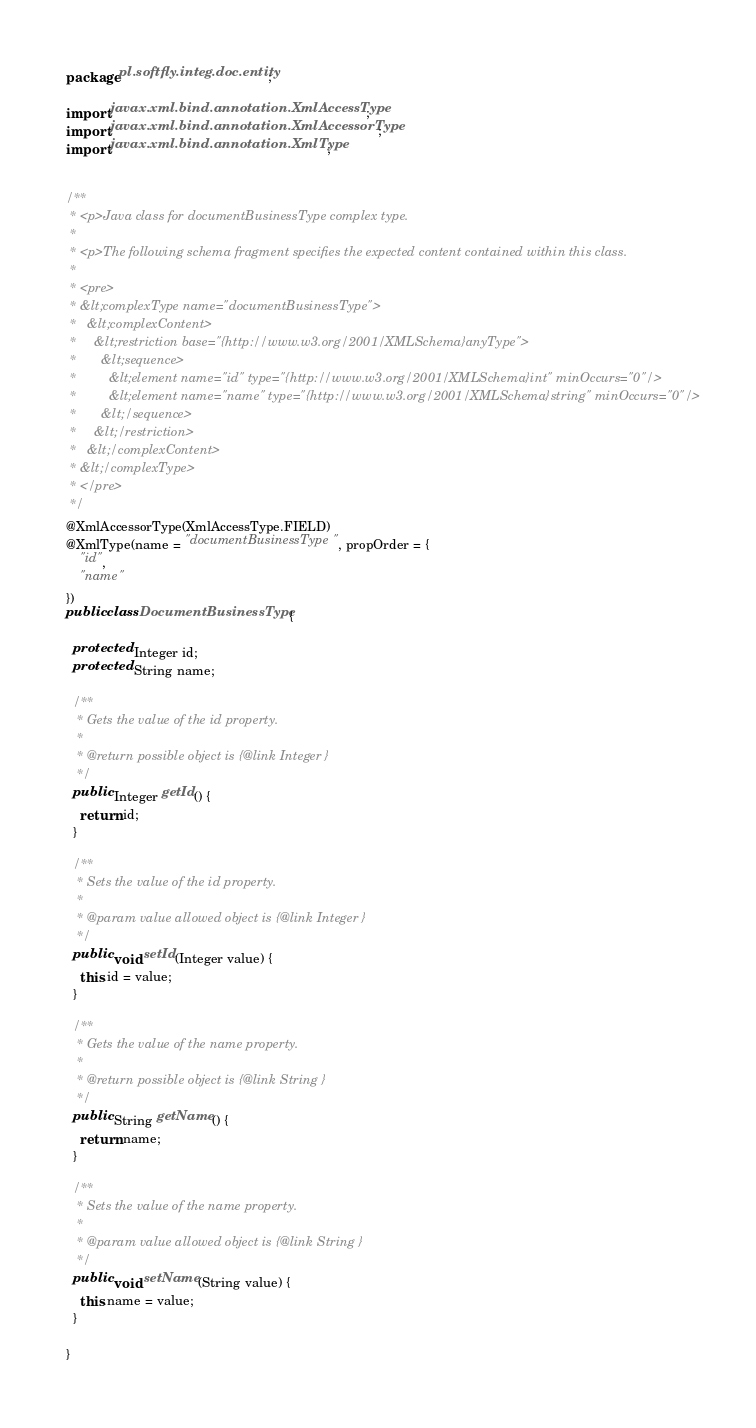<code> <loc_0><loc_0><loc_500><loc_500><_Java_>package pl.softfly.integ.doc.entity;

import javax.xml.bind.annotation.XmlAccessType;
import javax.xml.bind.annotation.XmlAccessorType;
import javax.xml.bind.annotation.XmlType;


/**
 * <p>Java class for documentBusinessType complex type.
 *
 * <p>The following schema fragment specifies the expected content contained within this class.
 *
 * <pre>
 * &lt;complexType name="documentBusinessType">
 *   &lt;complexContent>
 *     &lt;restriction base="{http://www.w3.org/2001/XMLSchema}anyType">
 *       &lt;sequence>
 *         &lt;element name="id" type="{http://www.w3.org/2001/XMLSchema}int" minOccurs="0"/>
 *         &lt;element name="name" type="{http://www.w3.org/2001/XMLSchema}string" minOccurs="0"/>
 *       &lt;/sequence>
 *     &lt;/restriction>
 *   &lt;/complexContent>
 * &lt;/complexType>
 * </pre>
 */
@XmlAccessorType(XmlAccessType.FIELD)
@XmlType(name = "documentBusinessType", propOrder = {
    "id",
    "name"
})
public class DocumentBusinessType {

  protected Integer id;
  protected String name;

  /**
   * Gets the value of the id property.
   *
   * @return possible object is {@link Integer }
   */
  public Integer getId() {
    return id;
  }

  /**
   * Sets the value of the id property.
   *
   * @param value allowed object is {@link Integer }
   */
  public void setId(Integer value) {
    this.id = value;
  }

  /**
   * Gets the value of the name property.
   *
   * @return possible object is {@link String }
   */
  public String getName() {
    return name;
  }

  /**
   * Sets the value of the name property.
   *
   * @param value allowed object is {@link String }
   */
  public void setName(String value) {
    this.name = value;
  }

}
</code> 